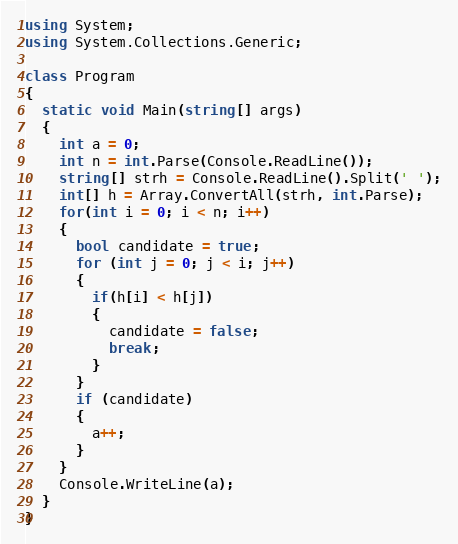<code> <loc_0><loc_0><loc_500><loc_500><_C#_>using System;
using System.Collections.Generic;

class Program
{
  static void Main(string[] args)
  {
    int a = 0;
    int n = int.Parse(Console.ReadLine());
    string[] strh = Console.ReadLine().Split(' ');
    int[] h = Array.ConvertAll(strh, int.Parse);
	for(int i = 0; i < n; i++)
    {
      bool candidate = true;
      for (int j = 0; j < i; j++)
      {
        if(h[i] < h[j])
        {
          candidate = false;
          break;
        }
      }
      if (candidate)
      {
        a++; 
      }  
    }
    Console.WriteLine(a);
  }
}</code> 